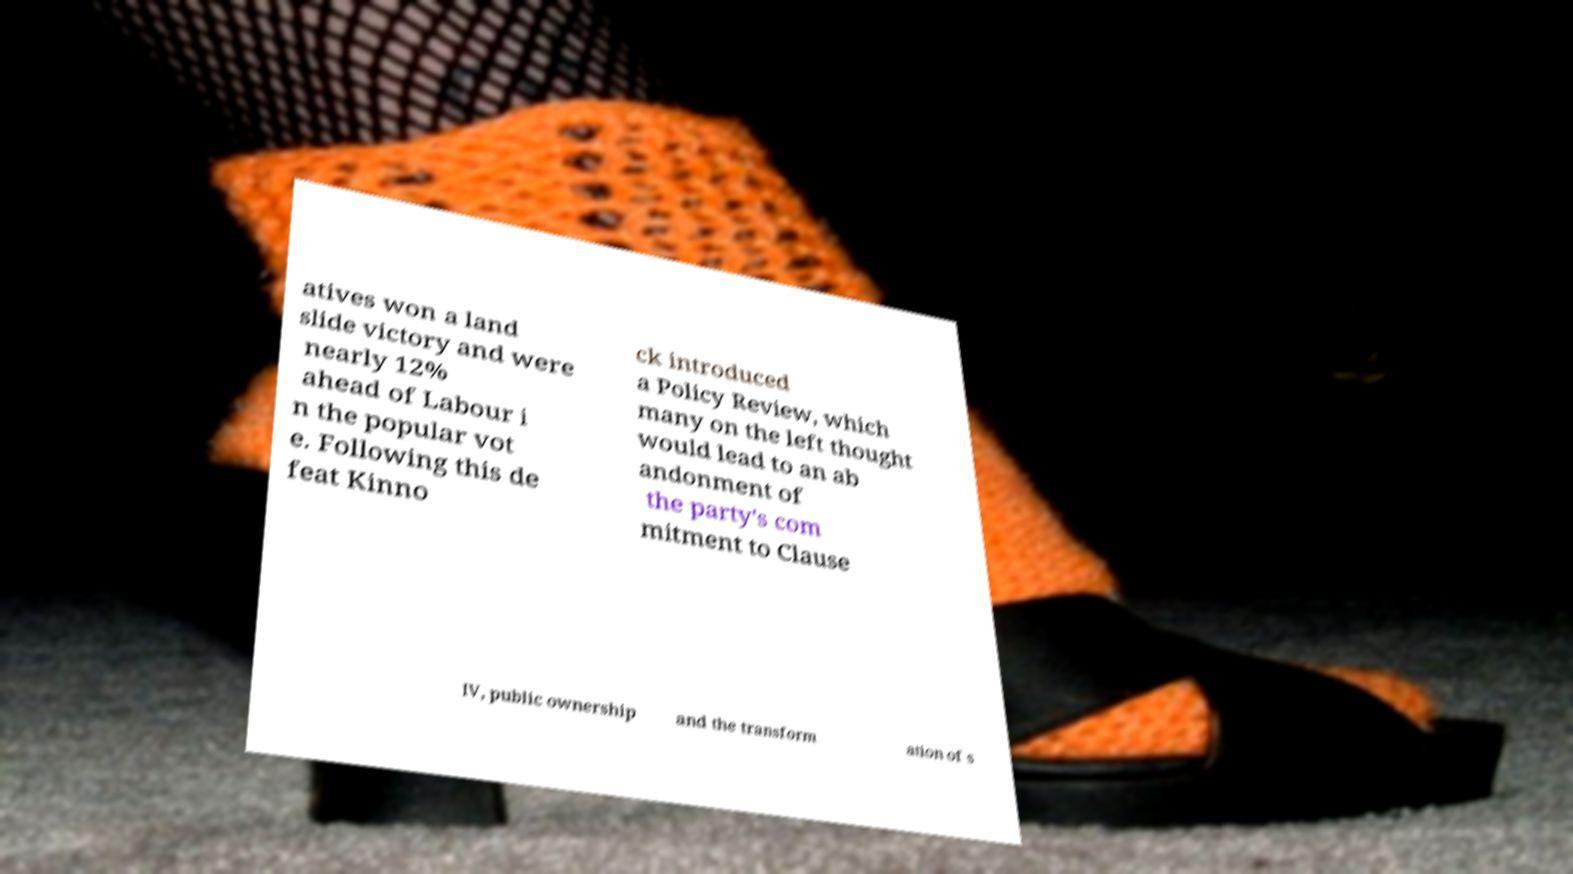Can you read and provide the text displayed in the image?This photo seems to have some interesting text. Can you extract and type it out for me? atives won a land slide victory and were nearly 12% ahead of Labour i n the popular vot e. Following this de feat Kinno ck introduced a Policy Review, which many on the left thought would lead to an ab andonment of the party's com mitment to Clause IV, public ownership and the transform ation of s 